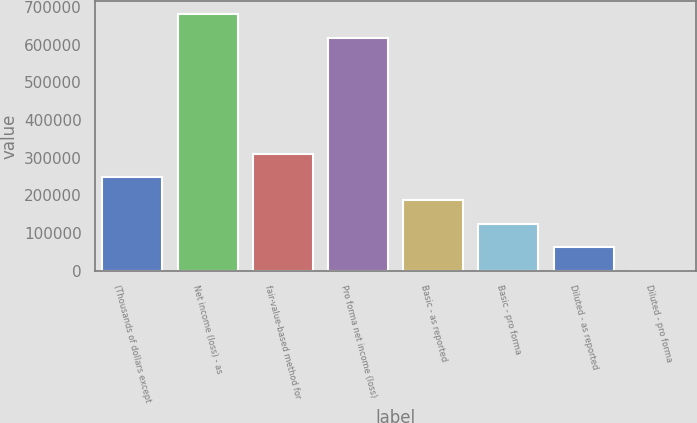Convert chart to OTSL. <chart><loc_0><loc_0><loc_500><loc_500><bar_chart><fcel>(Thousands of dollars except<fcel>Net income (loss) - as<fcel>fair-value-based method for<fcel>Pro forma net income (loss)<fcel>Basic - as reported<fcel>Basic - pro forma<fcel>Diluted - as reported<fcel>Diluted - pro forma<nl><fcel>248958<fcel>680734<fcel>311197<fcel>618495<fcel>186719<fcel>124480<fcel>62240.5<fcel>1.49<nl></chart> 